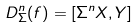<formula> <loc_0><loc_0><loc_500><loc_500>D _ { \Sigma } ^ { n } ( f ) = [ \Sigma ^ { n } X , Y ]</formula> 